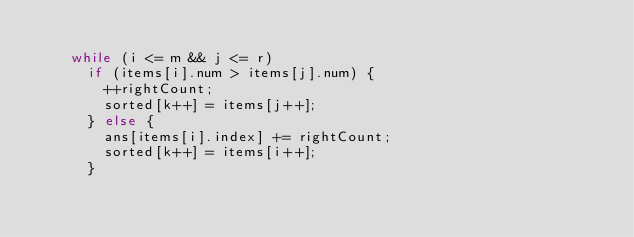Convert code to text. <code><loc_0><loc_0><loc_500><loc_500><_Java_>
    while (i <= m && j <= r)
      if (items[i].num > items[j].num) {
        ++rightCount;
        sorted[k++] = items[j++];
      } else {
        ans[items[i].index] += rightCount;
        sorted[k++] = items[i++];
      }
</code> 